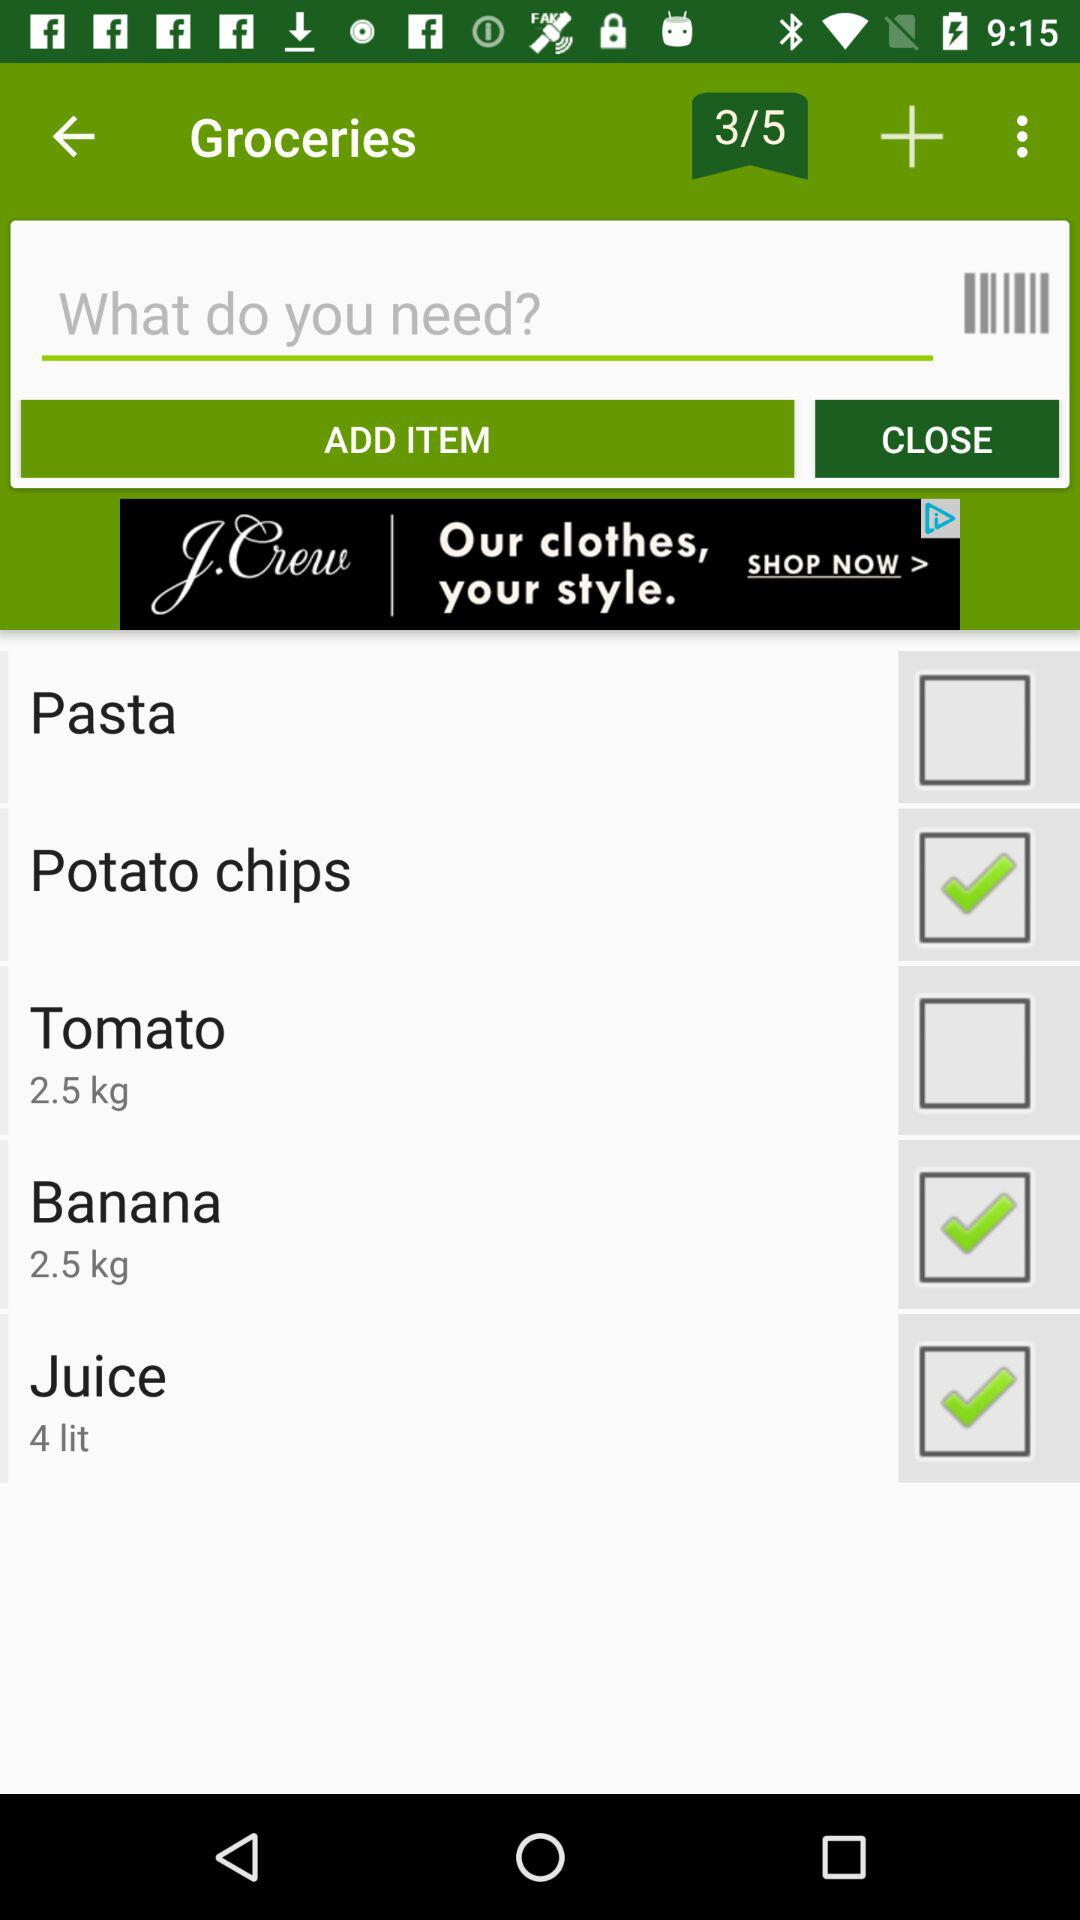How many liters of juice are selected? There are 4 liters of juice selected. 